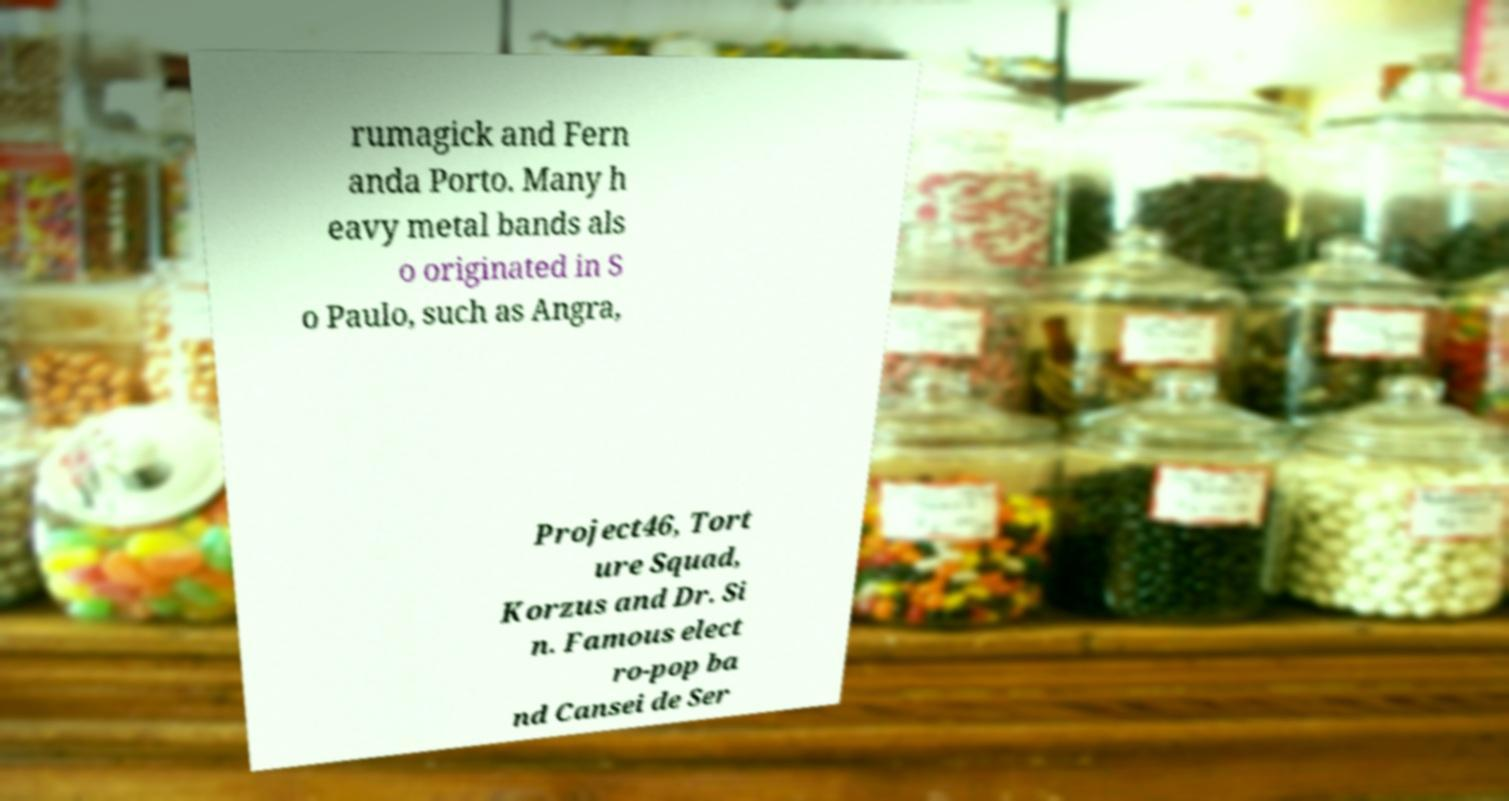Please identify and transcribe the text found in this image. rumagick and Fern anda Porto. Many h eavy metal bands als o originated in S o Paulo, such as Angra, Project46, Tort ure Squad, Korzus and Dr. Si n. Famous elect ro-pop ba nd Cansei de Ser 